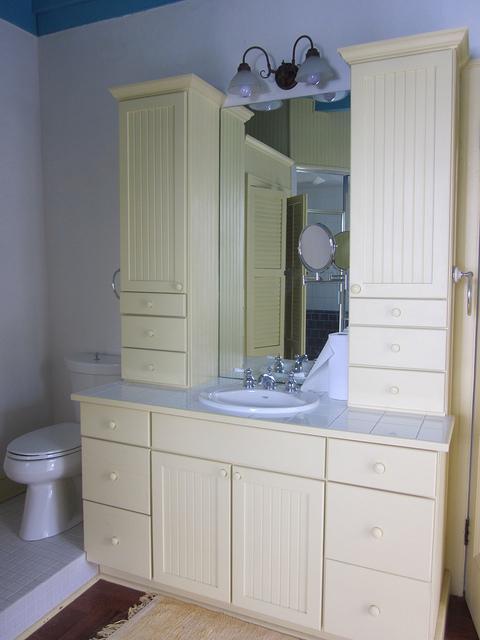How many knobs on the dresser?
Give a very brief answer. 12. 